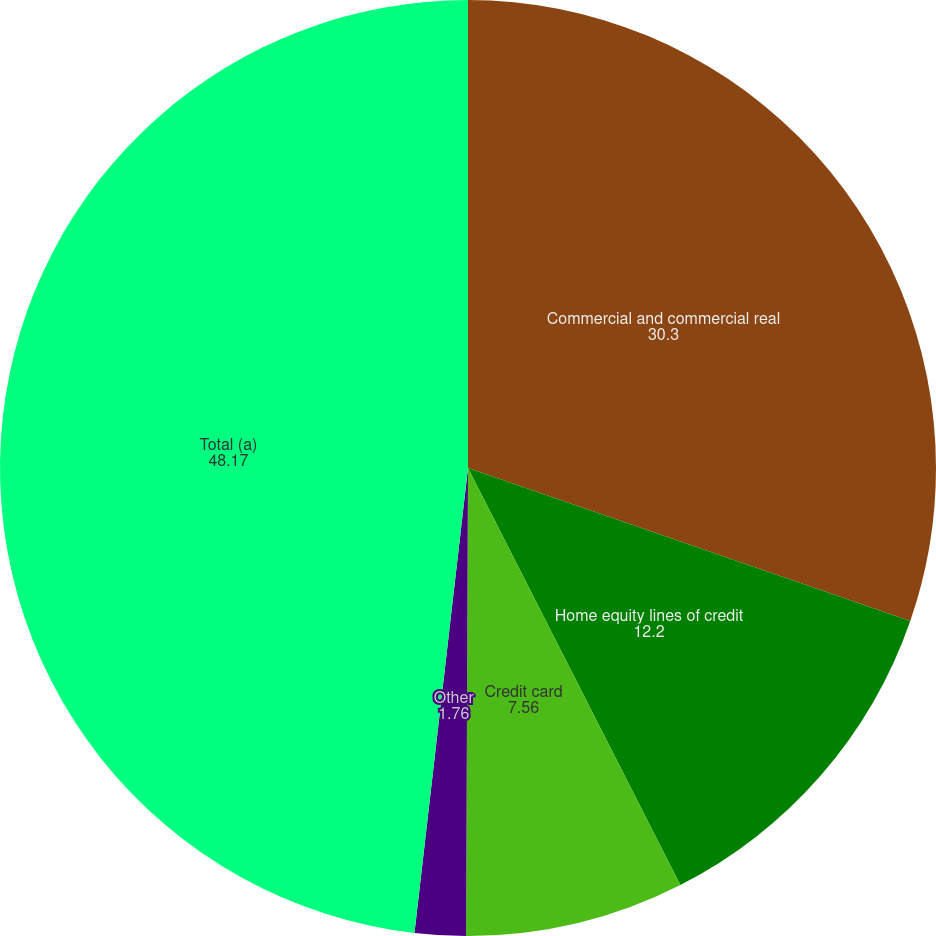Convert chart to OTSL. <chart><loc_0><loc_0><loc_500><loc_500><pie_chart><fcel>Commercial and commercial real<fcel>Home equity lines of credit<fcel>Credit card<fcel>Other<fcel>Total (a)<nl><fcel>30.3%<fcel>12.2%<fcel>7.56%<fcel>1.76%<fcel>48.17%<nl></chart> 